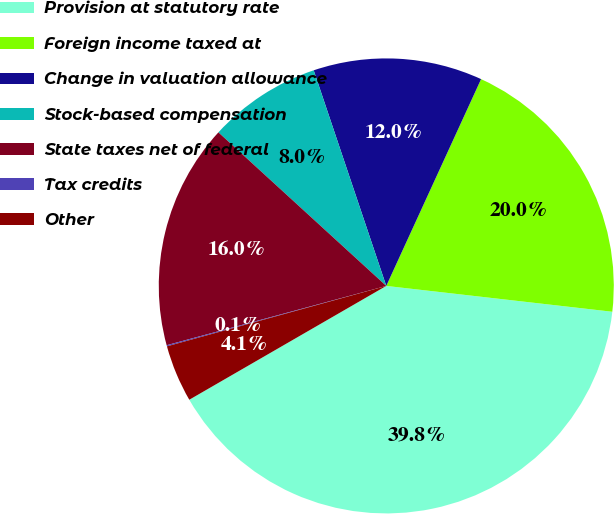<chart> <loc_0><loc_0><loc_500><loc_500><pie_chart><fcel>Provision at statutory rate<fcel>Foreign income taxed at<fcel>Change in valuation allowance<fcel>Stock-based compensation<fcel>State taxes net of federal<fcel>Tax credits<fcel>Other<nl><fcel>39.85%<fcel>19.97%<fcel>12.01%<fcel>8.04%<fcel>15.99%<fcel>0.08%<fcel>4.06%<nl></chart> 